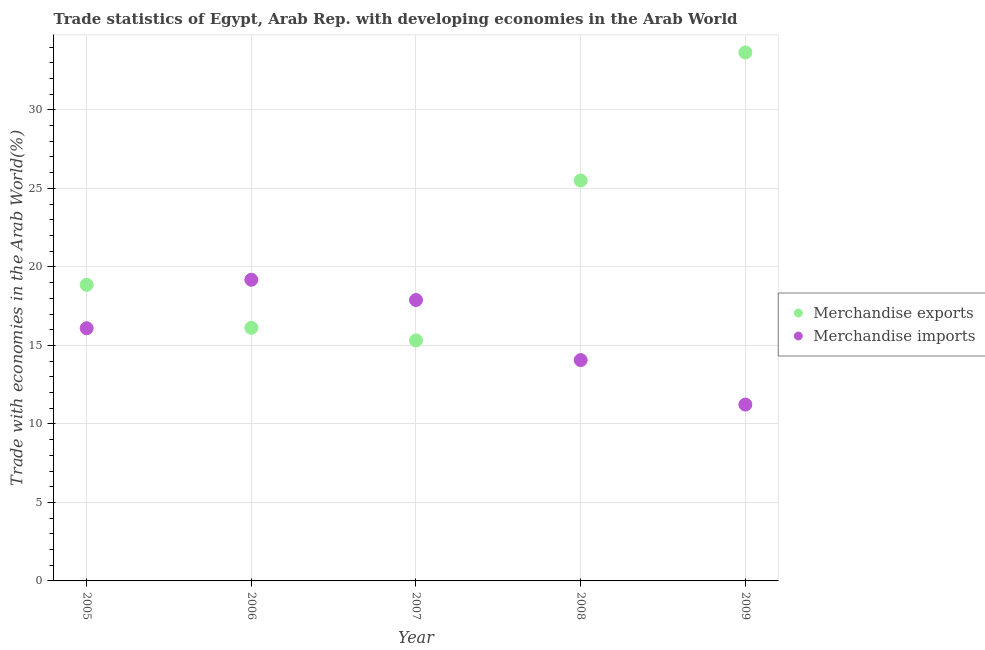Is the number of dotlines equal to the number of legend labels?
Your answer should be compact. Yes. What is the merchandise exports in 2008?
Your answer should be very brief. 25.5. Across all years, what is the maximum merchandise imports?
Provide a succinct answer. 19.18. Across all years, what is the minimum merchandise imports?
Provide a succinct answer. 11.23. In which year was the merchandise imports maximum?
Offer a very short reply. 2006. In which year was the merchandise imports minimum?
Provide a succinct answer. 2009. What is the total merchandise exports in the graph?
Give a very brief answer. 109.45. What is the difference between the merchandise imports in 2008 and that in 2009?
Provide a succinct answer. 2.83. What is the difference between the merchandise exports in 2009 and the merchandise imports in 2005?
Offer a terse response. 17.56. What is the average merchandise imports per year?
Your answer should be very brief. 15.69. In the year 2005, what is the difference between the merchandise exports and merchandise imports?
Make the answer very short. 2.76. In how many years, is the merchandise imports greater than 30 %?
Your response must be concise. 0. What is the ratio of the merchandise exports in 2005 to that in 2008?
Offer a very short reply. 0.74. What is the difference between the highest and the second highest merchandise imports?
Ensure brevity in your answer.  1.29. What is the difference between the highest and the lowest merchandise exports?
Provide a short and direct response. 18.34. In how many years, is the merchandise imports greater than the average merchandise imports taken over all years?
Provide a succinct answer. 3. Is the merchandise imports strictly greater than the merchandise exports over the years?
Provide a short and direct response. No. What is the difference between two consecutive major ticks on the Y-axis?
Your response must be concise. 5. Does the graph contain any zero values?
Your answer should be compact. No. Where does the legend appear in the graph?
Keep it short and to the point. Center right. How are the legend labels stacked?
Keep it short and to the point. Vertical. What is the title of the graph?
Give a very brief answer. Trade statistics of Egypt, Arab Rep. with developing economies in the Arab World. Does "GDP at market prices" appear as one of the legend labels in the graph?
Your answer should be very brief. No. What is the label or title of the Y-axis?
Provide a succinct answer. Trade with economies in the Arab World(%). What is the Trade with economies in the Arab World(%) in Merchandise exports in 2005?
Your response must be concise. 18.86. What is the Trade with economies in the Arab World(%) in Merchandise imports in 2005?
Provide a succinct answer. 16.09. What is the Trade with economies in the Arab World(%) of Merchandise exports in 2006?
Offer a terse response. 16.12. What is the Trade with economies in the Arab World(%) in Merchandise imports in 2006?
Ensure brevity in your answer.  19.18. What is the Trade with economies in the Arab World(%) in Merchandise exports in 2007?
Make the answer very short. 15.32. What is the Trade with economies in the Arab World(%) in Merchandise imports in 2007?
Make the answer very short. 17.89. What is the Trade with economies in the Arab World(%) in Merchandise exports in 2008?
Offer a very short reply. 25.5. What is the Trade with economies in the Arab World(%) of Merchandise imports in 2008?
Provide a succinct answer. 14.06. What is the Trade with economies in the Arab World(%) in Merchandise exports in 2009?
Make the answer very short. 33.66. What is the Trade with economies in the Arab World(%) of Merchandise imports in 2009?
Your answer should be very brief. 11.23. Across all years, what is the maximum Trade with economies in the Arab World(%) in Merchandise exports?
Provide a short and direct response. 33.66. Across all years, what is the maximum Trade with economies in the Arab World(%) of Merchandise imports?
Give a very brief answer. 19.18. Across all years, what is the minimum Trade with economies in the Arab World(%) in Merchandise exports?
Provide a succinct answer. 15.32. Across all years, what is the minimum Trade with economies in the Arab World(%) in Merchandise imports?
Your answer should be very brief. 11.23. What is the total Trade with economies in the Arab World(%) in Merchandise exports in the graph?
Your answer should be very brief. 109.45. What is the total Trade with economies in the Arab World(%) in Merchandise imports in the graph?
Provide a short and direct response. 78.46. What is the difference between the Trade with economies in the Arab World(%) of Merchandise exports in 2005 and that in 2006?
Give a very brief answer. 2.74. What is the difference between the Trade with economies in the Arab World(%) in Merchandise imports in 2005 and that in 2006?
Provide a short and direct response. -3.09. What is the difference between the Trade with economies in the Arab World(%) of Merchandise exports in 2005 and that in 2007?
Give a very brief answer. 3.54. What is the difference between the Trade with economies in the Arab World(%) of Merchandise imports in 2005 and that in 2007?
Make the answer very short. -1.8. What is the difference between the Trade with economies in the Arab World(%) of Merchandise exports in 2005 and that in 2008?
Provide a short and direct response. -6.64. What is the difference between the Trade with economies in the Arab World(%) of Merchandise imports in 2005 and that in 2008?
Ensure brevity in your answer.  2.03. What is the difference between the Trade with economies in the Arab World(%) of Merchandise exports in 2005 and that in 2009?
Provide a succinct answer. -14.8. What is the difference between the Trade with economies in the Arab World(%) in Merchandise imports in 2005 and that in 2009?
Make the answer very short. 4.86. What is the difference between the Trade with economies in the Arab World(%) in Merchandise exports in 2006 and that in 2007?
Provide a succinct answer. 0.8. What is the difference between the Trade with economies in the Arab World(%) of Merchandise imports in 2006 and that in 2007?
Offer a terse response. 1.29. What is the difference between the Trade with economies in the Arab World(%) in Merchandise exports in 2006 and that in 2008?
Keep it short and to the point. -9.38. What is the difference between the Trade with economies in the Arab World(%) in Merchandise imports in 2006 and that in 2008?
Your answer should be compact. 5.12. What is the difference between the Trade with economies in the Arab World(%) in Merchandise exports in 2006 and that in 2009?
Provide a short and direct response. -17.54. What is the difference between the Trade with economies in the Arab World(%) in Merchandise imports in 2006 and that in 2009?
Your answer should be compact. 7.95. What is the difference between the Trade with economies in the Arab World(%) of Merchandise exports in 2007 and that in 2008?
Provide a short and direct response. -10.19. What is the difference between the Trade with economies in the Arab World(%) in Merchandise imports in 2007 and that in 2008?
Ensure brevity in your answer.  3.83. What is the difference between the Trade with economies in the Arab World(%) in Merchandise exports in 2007 and that in 2009?
Offer a very short reply. -18.34. What is the difference between the Trade with economies in the Arab World(%) of Merchandise imports in 2007 and that in 2009?
Offer a terse response. 6.66. What is the difference between the Trade with economies in the Arab World(%) in Merchandise exports in 2008 and that in 2009?
Ensure brevity in your answer.  -8.15. What is the difference between the Trade with economies in the Arab World(%) of Merchandise imports in 2008 and that in 2009?
Your response must be concise. 2.83. What is the difference between the Trade with economies in the Arab World(%) in Merchandise exports in 2005 and the Trade with economies in the Arab World(%) in Merchandise imports in 2006?
Provide a short and direct response. -0.32. What is the difference between the Trade with economies in the Arab World(%) of Merchandise exports in 2005 and the Trade with economies in the Arab World(%) of Merchandise imports in 2007?
Keep it short and to the point. 0.97. What is the difference between the Trade with economies in the Arab World(%) in Merchandise exports in 2005 and the Trade with economies in the Arab World(%) in Merchandise imports in 2008?
Offer a very short reply. 4.79. What is the difference between the Trade with economies in the Arab World(%) in Merchandise exports in 2005 and the Trade with economies in the Arab World(%) in Merchandise imports in 2009?
Your answer should be compact. 7.63. What is the difference between the Trade with economies in the Arab World(%) in Merchandise exports in 2006 and the Trade with economies in the Arab World(%) in Merchandise imports in 2007?
Give a very brief answer. -1.77. What is the difference between the Trade with economies in the Arab World(%) in Merchandise exports in 2006 and the Trade with economies in the Arab World(%) in Merchandise imports in 2008?
Offer a terse response. 2.06. What is the difference between the Trade with economies in the Arab World(%) in Merchandise exports in 2006 and the Trade with economies in the Arab World(%) in Merchandise imports in 2009?
Provide a short and direct response. 4.89. What is the difference between the Trade with economies in the Arab World(%) in Merchandise exports in 2007 and the Trade with economies in the Arab World(%) in Merchandise imports in 2008?
Offer a terse response. 1.25. What is the difference between the Trade with economies in the Arab World(%) of Merchandise exports in 2007 and the Trade with economies in the Arab World(%) of Merchandise imports in 2009?
Your response must be concise. 4.09. What is the difference between the Trade with economies in the Arab World(%) in Merchandise exports in 2008 and the Trade with economies in the Arab World(%) in Merchandise imports in 2009?
Offer a terse response. 14.27. What is the average Trade with economies in the Arab World(%) in Merchandise exports per year?
Your response must be concise. 21.89. What is the average Trade with economies in the Arab World(%) of Merchandise imports per year?
Provide a succinct answer. 15.69. In the year 2005, what is the difference between the Trade with economies in the Arab World(%) of Merchandise exports and Trade with economies in the Arab World(%) of Merchandise imports?
Keep it short and to the point. 2.76. In the year 2006, what is the difference between the Trade with economies in the Arab World(%) of Merchandise exports and Trade with economies in the Arab World(%) of Merchandise imports?
Keep it short and to the point. -3.06. In the year 2007, what is the difference between the Trade with economies in the Arab World(%) in Merchandise exports and Trade with economies in the Arab World(%) in Merchandise imports?
Your answer should be compact. -2.57. In the year 2008, what is the difference between the Trade with economies in the Arab World(%) of Merchandise exports and Trade with economies in the Arab World(%) of Merchandise imports?
Offer a terse response. 11.44. In the year 2009, what is the difference between the Trade with economies in the Arab World(%) in Merchandise exports and Trade with economies in the Arab World(%) in Merchandise imports?
Keep it short and to the point. 22.43. What is the ratio of the Trade with economies in the Arab World(%) in Merchandise exports in 2005 to that in 2006?
Your response must be concise. 1.17. What is the ratio of the Trade with economies in the Arab World(%) in Merchandise imports in 2005 to that in 2006?
Your response must be concise. 0.84. What is the ratio of the Trade with economies in the Arab World(%) in Merchandise exports in 2005 to that in 2007?
Offer a very short reply. 1.23. What is the ratio of the Trade with economies in the Arab World(%) of Merchandise imports in 2005 to that in 2007?
Give a very brief answer. 0.9. What is the ratio of the Trade with economies in the Arab World(%) in Merchandise exports in 2005 to that in 2008?
Your response must be concise. 0.74. What is the ratio of the Trade with economies in the Arab World(%) in Merchandise imports in 2005 to that in 2008?
Provide a short and direct response. 1.14. What is the ratio of the Trade with economies in the Arab World(%) in Merchandise exports in 2005 to that in 2009?
Your answer should be compact. 0.56. What is the ratio of the Trade with economies in the Arab World(%) in Merchandise imports in 2005 to that in 2009?
Give a very brief answer. 1.43. What is the ratio of the Trade with economies in the Arab World(%) in Merchandise exports in 2006 to that in 2007?
Make the answer very short. 1.05. What is the ratio of the Trade with economies in the Arab World(%) of Merchandise imports in 2006 to that in 2007?
Make the answer very short. 1.07. What is the ratio of the Trade with economies in the Arab World(%) of Merchandise exports in 2006 to that in 2008?
Offer a terse response. 0.63. What is the ratio of the Trade with economies in the Arab World(%) of Merchandise imports in 2006 to that in 2008?
Offer a terse response. 1.36. What is the ratio of the Trade with economies in the Arab World(%) of Merchandise exports in 2006 to that in 2009?
Keep it short and to the point. 0.48. What is the ratio of the Trade with economies in the Arab World(%) of Merchandise imports in 2006 to that in 2009?
Ensure brevity in your answer.  1.71. What is the ratio of the Trade with economies in the Arab World(%) in Merchandise exports in 2007 to that in 2008?
Offer a very short reply. 0.6. What is the ratio of the Trade with economies in the Arab World(%) in Merchandise imports in 2007 to that in 2008?
Provide a short and direct response. 1.27. What is the ratio of the Trade with economies in the Arab World(%) of Merchandise exports in 2007 to that in 2009?
Ensure brevity in your answer.  0.46. What is the ratio of the Trade with economies in the Arab World(%) of Merchandise imports in 2007 to that in 2009?
Ensure brevity in your answer.  1.59. What is the ratio of the Trade with economies in the Arab World(%) in Merchandise exports in 2008 to that in 2009?
Offer a very short reply. 0.76. What is the ratio of the Trade with economies in the Arab World(%) in Merchandise imports in 2008 to that in 2009?
Your answer should be compact. 1.25. What is the difference between the highest and the second highest Trade with economies in the Arab World(%) in Merchandise exports?
Make the answer very short. 8.15. What is the difference between the highest and the second highest Trade with economies in the Arab World(%) of Merchandise imports?
Your response must be concise. 1.29. What is the difference between the highest and the lowest Trade with economies in the Arab World(%) in Merchandise exports?
Ensure brevity in your answer.  18.34. What is the difference between the highest and the lowest Trade with economies in the Arab World(%) in Merchandise imports?
Offer a terse response. 7.95. 